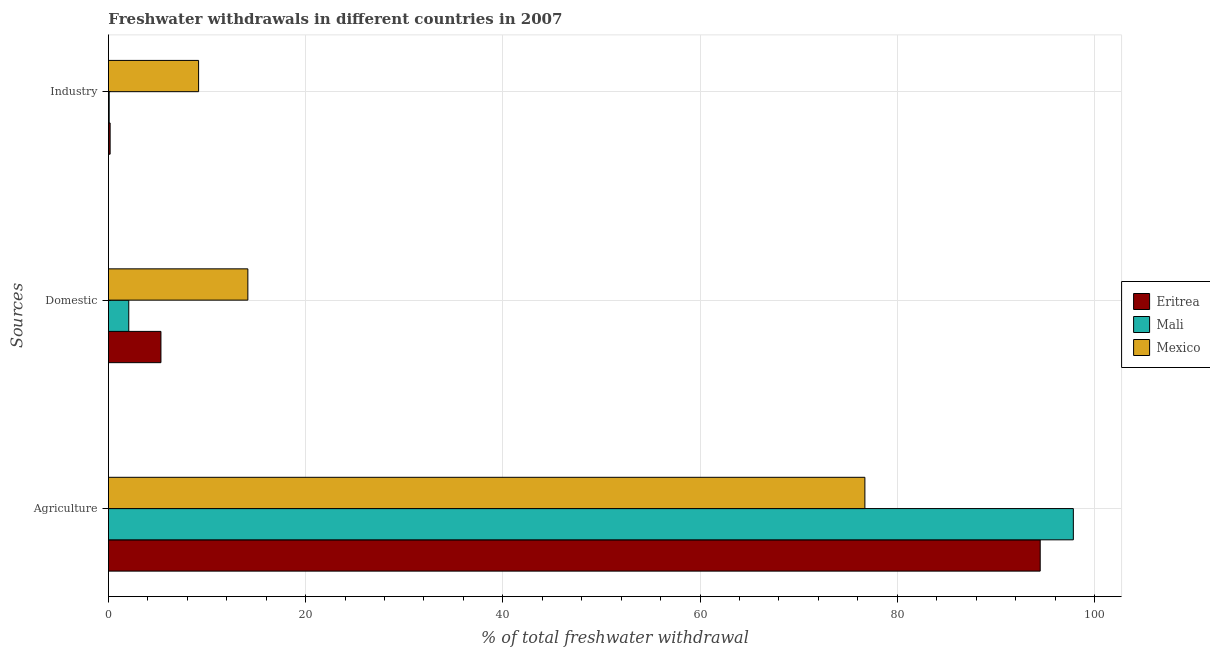How many different coloured bars are there?
Your answer should be very brief. 3. How many groups of bars are there?
Offer a very short reply. 3. How many bars are there on the 2nd tick from the top?
Provide a short and direct response. 3. How many bars are there on the 3rd tick from the bottom?
Give a very brief answer. 3. What is the label of the 2nd group of bars from the top?
Your answer should be very brief. Domestic. What is the percentage of freshwater withdrawal for domestic purposes in Mexico?
Keep it short and to the point. 14.14. Across all countries, what is the maximum percentage of freshwater withdrawal for industry?
Offer a very short reply. 9.14. Across all countries, what is the minimum percentage of freshwater withdrawal for industry?
Ensure brevity in your answer.  0.08. In which country was the percentage of freshwater withdrawal for industry minimum?
Provide a succinct answer. Mali. What is the total percentage of freshwater withdrawal for domestic purposes in the graph?
Ensure brevity in your answer.  21.53. What is the difference between the percentage of freshwater withdrawal for domestic purposes in Eritrea and that in Mexico?
Offer a very short reply. -8.81. What is the difference between the percentage of freshwater withdrawal for industry in Eritrea and the percentage of freshwater withdrawal for domestic purposes in Mexico?
Offer a terse response. -13.97. What is the average percentage of freshwater withdrawal for domestic purposes per country?
Offer a very short reply. 7.18. What is the difference between the percentage of freshwater withdrawal for agriculture and percentage of freshwater withdrawal for domestic purposes in Mexico?
Keep it short and to the point. 62.58. What is the ratio of the percentage of freshwater withdrawal for agriculture in Mali to that in Mexico?
Keep it short and to the point. 1.28. Is the difference between the percentage of freshwater withdrawal for industry in Eritrea and Mexico greater than the difference between the percentage of freshwater withdrawal for domestic purposes in Eritrea and Mexico?
Provide a succinct answer. No. What is the difference between the highest and the second highest percentage of freshwater withdrawal for agriculture?
Your response must be concise. 3.36. What is the difference between the highest and the lowest percentage of freshwater withdrawal for agriculture?
Make the answer very short. 21.14. What does the 3rd bar from the top in Domestic represents?
Provide a short and direct response. Eritrea. What does the 1st bar from the bottom in Industry represents?
Offer a terse response. Eritrea. Are the values on the major ticks of X-axis written in scientific E-notation?
Your response must be concise. No. Does the graph contain any zero values?
Offer a terse response. No. Does the graph contain grids?
Ensure brevity in your answer.  Yes. Where does the legend appear in the graph?
Your response must be concise. Center right. How many legend labels are there?
Give a very brief answer. 3. How are the legend labels stacked?
Ensure brevity in your answer.  Vertical. What is the title of the graph?
Offer a very short reply. Freshwater withdrawals in different countries in 2007. Does "Belgium" appear as one of the legend labels in the graph?
Keep it short and to the point. No. What is the label or title of the X-axis?
Make the answer very short. % of total freshwater withdrawal. What is the label or title of the Y-axis?
Make the answer very short. Sources. What is the % of total freshwater withdrawal of Eritrea in Agriculture?
Offer a terse response. 94.5. What is the % of total freshwater withdrawal of Mali in Agriculture?
Provide a succinct answer. 97.86. What is the % of total freshwater withdrawal of Mexico in Agriculture?
Your response must be concise. 76.72. What is the % of total freshwater withdrawal of Eritrea in Domestic?
Give a very brief answer. 5.33. What is the % of total freshwater withdrawal of Mali in Domestic?
Offer a very short reply. 2.06. What is the % of total freshwater withdrawal of Mexico in Domestic?
Your answer should be very brief. 14.14. What is the % of total freshwater withdrawal of Eritrea in Industry?
Keep it short and to the point. 0.17. What is the % of total freshwater withdrawal in Mali in Industry?
Keep it short and to the point. 0.08. What is the % of total freshwater withdrawal of Mexico in Industry?
Your answer should be compact. 9.14. Across all Sources, what is the maximum % of total freshwater withdrawal of Eritrea?
Your answer should be compact. 94.5. Across all Sources, what is the maximum % of total freshwater withdrawal of Mali?
Your answer should be very brief. 97.86. Across all Sources, what is the maximum % of total freshwater withdrawal of Mexico?
Offer a very short reply. 76.72. Across all Sources, what is the minimum % of total freshwater withdrawal in Eritrea?
Provide a succinct answer. 0.17. Across all Sources, what is the minimum % of total freshwater withdrawal in Mali?
Offer a terse response. 0.08. Across all Sources, what is the minimum % of total freshwater withdrawal in Mexico?
Offer a very short reply. 9.14. What is the total % of total freshwater withdrawal of Eritrea in the graph?
Offer a very short reply. 100. What is the total % of total freshwater withdrawal of Mali in the graph?
Ensure brevity in your answer.  100. What is the total % of total freshwater withdrawal in Mexico in the graph?
Offer a terse response. 100. What is the difference between the % of total freshwater withdrawal of Eritrea in Agriculture and that in Domestic?
Ensure brevity in your answer.  89.17. What is the difference between the % of total freshwater withdrawal of Mali in Agriculture and that in Domestic?
Keep it short and to the point. 95.8. What is the difference between the % of total freshwater withdrawal of Mexico in Agriculture and that in Domestic?
Ensure brevity in your answer.  62.58. What is the difference between the % of total freshwater withdrawal of Eritrea in Agriculture and that in Industry?
Your response must be concise. 94.33. What is the difference between the % of total freshwater withdrawal of Mali in Agriculture and that in Industry?
Your answer should be very brief. 97.78. What is the difference between the % of total freshwater withdrawal of Mexico in Agriculture and that in Industry?
Offer a terse response. 67.58. What is the difference between the % of total freshwater withdrawal of Eritrea in Domestic and that in Industry?
Provide a succinct answer. 5.15. What is the difference between the % of total freshwater withdrawal of Mali in Domestic and that in Industry?
Your answer should be very brief. 1.99. What is the difference between the % of total freshwater withdrawal in Mexico in Domestic and that in Industry?
Keep it short and to the point. 5. What is the difference between the % of total freshwater withdrawal of Eritrea in Agriculture and the % of total freshwater withdrawal of Mali in Domestic?
Your response must be concise. 92.44. What is the difference between the % of total freshwater withdrawal in Eritrea in Agriculture and the % of total freshwater withdrawal in Mexico in Domestic?
Give a very brief answer. 80.36. What is the difference between the % of total freshwater withdrawal of Mali in Agriculture and the % of total freshwater withdrawal of Mexico in Domestic?
Keep it short and to the point. 83.72. What is the difference between the % of total freshwater withdrawal in Eritrea in Agriculture and the % of total freshwater withdrawal in Mali in Industry?
Keep it short and to the point. 94.42. What is the difference between the % of total freshwater withdrawal in Eritrea in Agriculture and the % of total freshwater withdrawal in Mexico in Industry?
Your answer should be very brief. 85.36. What is the difference between the % of total freshwater withdrawal in Mali in Agriculture and the % of total freshwater withdrawal in Mexico in Industry?
Provide a short and direct response. 88.72. What is the difference between the % of total freshwater withdrawal of Eritrea in Domestic and the % of total freshwater withdrawal of Mali in Industry?
Your answer should be compact. 5.25. What is the difference between the % of total freshwater withdrawal of Eritrea in Domestic and the % of total freshwater withdrawal of Mexico in Industry?
Offer a terse response. -3.82. What is the difference between the % of total freshwater withdrawal in Mali in Domestic and the % of total freshwater withdrawal in Mexico in Industry?
Make the answer very short. -7.08. What is the average % of total freshwater withdrawal in Eritrea per Sources?
Your response must be concise. 33.33. What is the average % of total freshwater withdrawal in Mali per Sources?
Your answer should be very brief. 33.33. What is the average % of total freshwater withdrawal in Mexico per Sources?
Keep it short and to the point. 33.34. What is the difference between the % of total freshwater withdrawal in Eritrea and % of total freshwater withdrawal in Mali in Agriculture?
Offer a very short reply. -3.36. What is the difference between the % of total freshwater withdrawal in Eritrea and % of total freshwater withdrawal in Mexico in Agriculture?
Make the answer very short. 17.78. What is the difference between the % of total freshwater withdrawal in Mali and % of total freshwater withdrawal in Mexico in Agriculture?
Ensure brevity in your answer.  21.14. What is the difference between the % of total freshwater withdrawal in Eritrea and % of total freshwater withdrawal in Mali in Domestic?
Ensure brevity in your answer.  3.26. What is the difference between the % of total freshwater withdrawal of Eritrea and % of total freshwater withdrawal of Mexico in Domestic?
Your response must be concise. -8.81. What is the difference between the % of total freshwater withdrawal of Mali and % of total freshwater withdrawal of Mexico in Domestic?
Offer a very short reply. -12.08. What is the difference between the % of total freshwater withdrawal in Eritrea and % of total freshwater withdrawal in Mali in Industry?
Offer a terse response. 0.09. What is the difference between the % of total freshwater withdrawal of Eritrea and % of total freshwater withdrawal of Mexico in Industry?
Provide a succinct answer. -8.97. What is the difference between the % of total freshwater withdrawal in Mali and % of total freshwater withdrawal in Mexico in Industry?
Ensure brevity in your answer.  -9.07. What is the ratio of the % of total freshwater withdrawal in Eritrea in Agriculture to that in Domestic?
Your answer should be compact. 17.74. What is the ratio of the % of total freshwater withdrawal in Mali in Agriculture to that in Domestic?
Your response must be concise. 47.44. What is the ratio of the % of total freshwater withdrawal in Mexico in Agriculture to that in Domestic?
Keep it short and to the point. 5.43. What is the ratio of the % of total freshwater withdrawal of Eritrea in Agriculture to that in Industry?
Give a very brief answer. 550.06. What is the ratio of the % of total freshwater withdrawal of Mali in Agriculture to that in Industry?
Offer a very short reply. 1269.26. What is the ratio of the % of total freshwater withdrawal of Mexico in Agriculture to that in Industry?
Offer a very short reply. 8.39. What is the ratio of the % of total freshwater withdrawal of Eritrea in Domestic to that in Industry?
Your answer should be compact. 31. What is the ratio of the % of total freshwater withdrawal in Mali in Domestic to that in Industry?
Provide a succinct answer. 26.76. What is the ratio of the % of total freshwater withdrawal of Mexico in Domestic to that in Industry?
Offer a very short reply. 1.55. What is the difference between the highest and the second highest % of total freshwater withdrawal in Eritrea?
Provide a short and direct response. 89.17. What is the difference between the highest and the second highest % of total freshwater withdrawal of Mali?
Provide a succinct answer. 95.8. What is the difference between the highest and the second highest % of total freshwater withdrawal of Mexico?
Offer a very short reply. 62.58. What is the difference between the highest and the lowest % of total freshwater withdrawal of Eritrea?
Your answer should be very brief. 94.33. What is the difference between the highest and the lowest % of total freshwater withdrawal of Mali?
Your response must be concise. 97.78. What is the difference between the highest and the lowest % of total freshwater withdrawal of Mexico?
Provide a succinct answer. 67.58. 